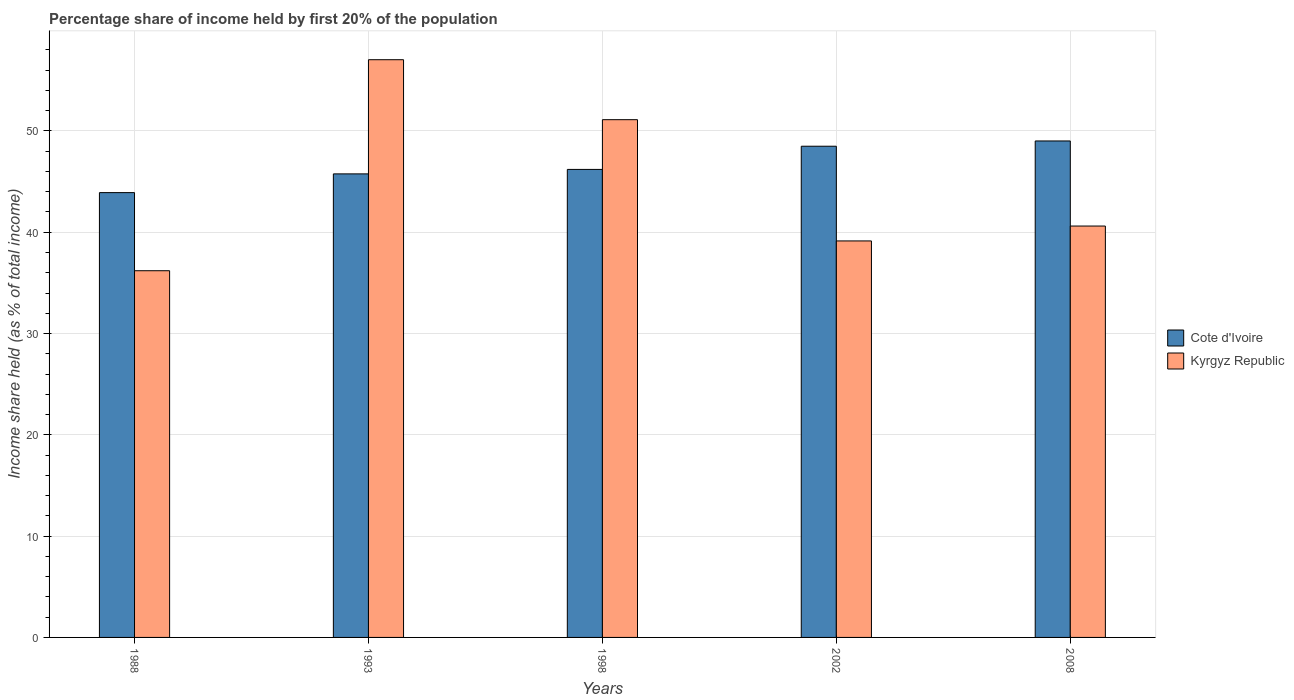Are the number of bars per tick equal to the number of legend labels?
Give a very brief answer. Yes. Are the number of bars on each tick of the X-axis equal?
Make the answer very short. Yes. What is the label of the 2nd group of bars from the left?
Your answer should be very brief. 1993. In how many cases, is the number of bars for a given year not equal to the number of legend labels?
Your answer should be very brief. 0. What is the share of income held by first 20% of the population in Kyrgyz Republic in 2008?
Give a very brief answer. 40.61. Across all years, what is the maximum share of income held by first 20% of the population in Cote d'Ivoire?
Your answer should be very brief. 49.01. Across all years, what is the minimum share of income held by first 20% of the population in Cote d'Ivoire?
Your answer should be very brief. 43.91. What is the total share of income held by first 20% of the population in Kyrgyz Republic in the graph?
Keep it short and to the point. 224.09. What is the difference between the share of income held by first 20% of the population in Kyrgyz Republic in 2002 and that in 2008?
Offer a terse response. -1.47. What is the difference between the share of income held by first 20% of the population in Kyrgyz Republic in 2008 and the share of income held by first 20% of the population in Cote d'Ivoire in 2002?
Keep it short and to the point. -7.88. What is the average share of income held by first 20% of the population in Kyrgyz Republic per year?
Give a very brief answer. 44.82. In the year 2008, what is the difference between the share of income held by first 20% of the population in Kyrgyz Republic and share of income held by first 20% of the population in Cote d'Ivoire?
Provide a succinct answer. -8.4. In how many years, is the share of income held by first 20% of the population in Cote d'Ivoire greater than 24 %?
Offer a terse response. 5. What is the ratio of the share of income held by first 20% of the population in Cote d'Ivoire in 2002 to that in 2008?
Offer a terse response. 0.99. What is the difference between the highest and the second highest share of income held by first 20% of the population in Cote d'Ivoire?
Your response must be concise. 0.52. What is the difference between the highest and the lowest share of income held by first 20% of the population in Kyrgyz Republic?
Keep it short and to the point. 20.83. Is the sum of the share of income held by first 20% of the population in Cote d'Ivoire in 1993 and 2008 greater than the maximum share of income held by first 20% of the population in Kyrgyz Republic across all years?
Offer a very short reply. Yes. What does the 1st bar from the left in 1988 represents?
Your response must be concise. Cote d'Ivoire. What does the 2nd bar from the right in 2002 represents?
Ensure brevity in your answer.  Cote d'Ivoire. How many bars are there?
Offer a very short reply. 10. How many years are there in the graph?
Provide a succinct answer. 5. What is the difference between two consecutive major ticks on the Y-axis?
Make the answer very short. 10. Does the graph contain grids?
Your response must be concise. Yes. Where does the legend appear in the graph?
Ensure brevity in your answer.  Center right. How many legend labels are there?
Offer a very short reply. 2. How are the legend labels stacked?
Offer a terse response. Vertical. What is the title of the graph?
Make the answer very short. Percentage share of income held by first 20% of the population. What is the label or title of the Y-axis?
Offer a very short reply. Income share held (as % of total income). What is the Income share held (as % of total income) in Cote d'Ivoire in 1988?
Your answer should be very brief. 43.91. What is the Income share held (as % of total income) in Kyrgyz Republic in 1988?
Your answer should be compact. 36.2. What is the Income share held (as % of total income) of Cote d'Ivoire in 1993?
Ensure brevity in your answer.  45.76. What is the Income share held (as % of total income) in Kyrgyz Republic in 1993?
Give a very brief answer. 57.03. What is the Income share held (as % of total income) of Cote d'Ivoire in 1998?
Ensure brevity in your answer.  46.2. What is the Income share held (as % of total income) in Kyrgyz Republic in 1998?
Provide a short and direct response. 51.11. What is the Income share held (as % of total income) in Cote d'Ivoire in 2002?
Your response must be concise. 48.49. What is the Income share held (as % of total income) in Kyrgyz Republic in 2002?
Your response must be concise. 39.14. What is the Income share held (as % of total income) in Cote d'Ivoire in 2008?
Offer a terse response. 49.01. What is the Income share held (as % of total income) of Kyrgyz Republic in 2008?
Offer a very short reply. 40.61. Across all years, what is the maximum Income share held (as % of total income) in Cote d'Ivoire?
Offer a terse response. 49.01. Across all years, what is the maximum Income share held (as % of total income) in Kyrgyz Republic?
Keep it short and to the point. 57.03. Across all years, what is the minimum Income share held (as % of total income) in Cote d'Ivoire?
Offer a very short reply. 43.91. Across all years, what is the minimum Income share held (as % of total income) of Kyrgyz Republic?
Give a very brief answer. 36.2. What is the total Income share held (as % of total income) in Cote d'Ivoire in the graph?
Your response must be concise. 233.37. What is the total Income share held (as % of total income) in Kyrgyz Republic in the graph?
Your answer should be compact. 224.09. What is the difference between the Income share held (as % of total income) of Cote d'Ivoire in 1988 and that in 1993?
Provide a succinct answer. -1.85. What is the difference between the Income share held (as % of total income) of Kyrgyz Republic in 1988 and that in 1993?
Offer a very short reply. -20.83. What is the difference between the Income share held (as % of total income) of Cote d'Ivoire in 1988 and that in 1998?
Keep it short and to the point. -2.29. What is the difference between the Income share held (as % of total income) of Kyrgyz Republic in 1988 and that in 1998?
Provide a succinct answer. -14.91. What is the difference between the Income share held (as % of total income) in Cote d'Ivoire in 1988 and that in 2002?
Keep it short and to the point. -4.58. What is the difference between the Income share held (as % of total income) of Kyrgyz Republic in 1988 and that in 2002?
Keep it short and to the point. -2.94. What is the difference between the Income share held (as % of total income) of Kyrgyz Republic in 1988 and that in 2008?
Your answer should be compact. -4.41. What is the difference between the Income share held (as % of total income) of Cote d'Ivoire in 1993 and that in 1998?
Your answer should be very brief. -0.44. What is the difference between the Income share held (as % of total income) in Kyrgyz Republic in 1993 and that in 1998?
Make the answer very short. 5.92. What is the difference between the Income share held (as % of total income) in Cote d'Ivoire in 1993 and that in 2002?
Provide a short and direct response. -2.73. What is the difference between the Income share held (as % of total income) of Kyrgyz Republic in 1993 and that in 2002?
Provide a short and direct response. 17.89. What is the difference between the Income share held (as % of total income) in Cote d'Ivoire in 1993 and that in 2008?
Keep it short and to the point. -3.25. What is the difference between the Income share held (as % of total income) in Kyrgyz Republic in 1993 and that in 2008?
Your response must be concise. 16.42. What is the difference between the Income share held (as % of total income) of Cote d'Ivoire in 1998 and that in 2002?
Make the answer very short. -2.29. What is the difference between the Income share held (as % of total income) in Kyrgyz Republic in 1998 and that in 2002?
Provide a succinct answer. 11.97. What is the difference between the Income share held (as % of total income) in Cote d'Ivoire in 1998 and that in 2008?
Offer a terse response. -2.81. What is the difference between the Income share held (as % of total income) of Cote d'Ivoire in 2002 and that in 2008?
Ensure brevity in your answer.  -0.52. What is the difference between the Income share held (as % of total income) in Kyrgyz Republic in 2002 and that in 2008?
Offer a terse response. -1.47. What is the difference between the Income share held (as % of total income) of Cote d'Ivoire in 1988 and the Income share held (as % of total income) of Kyrgyz Republic in 1993?
Provide a short and direct response. -13.12. What is the difference between the Income share held (as % of total income) of Cote d'Ivoire in 1988 and the Income share held (as % of total income) of Kyrgyz Republic in 2002?
Provide a succinct answer. 4.77. What is the difference between the Income share held (as % of total income) in Cote d'Ivoire in 1993 and the Income share held (as % of total income) in Kyrgyz Republic in 1998?
Provide a succinct answer. -5.35. What is the difference between the Income share held (as % of total income) of Cote d'Ivoire in 1993 and the Income share held (as % of total income) of Kyrgyz Republic in 2002?
Give a very brief answer. 6.62. What is the difference between the Income share held (as % of total income) of Cote d'Ivoire in 1993 and the Income share held (as % of total income) of Kyrgyz Republic in 2008?
Make the answer very short. 5.15. What is the difference between the Income share held (as % of total income) of Cote d'Ivoire in 1998 and the Income share held (as % of total income) of Kyrgyz Republic in 2002?
Keep it short and to the point. 7.06. What is the difference between the Income share held (as % of total income) in Cote d'Ivoire in 1998 and the Income share held (as % of total income) in Kyrgyz Republic in 2008?
Your response must be concise. 5.59. What is the difference between the Income share held (as % of total income) of Cote d'Ivoire in 2002 and the Income share held (as % of total income) of Kyrgyz Republic in 2008?
Your response must be concise. 7.88. What is the average Income share held (as % of total income) in Cote d'Ivoire per year?
Provide a short and direct response. 46.67. What is the average Income share held (as % of total income) in Kyrgyz Republic per year?
Your answer should be compact. 44.82. In the year 1988, what is the difference between the Income share held (as % of total income) in Cote d'Ivoire and Income share held (as % of total income) in Kyrgyz Republic?
Keep it short and to the point. 7.71. In the year 1993, what is the difference between the Income share held (as % of total income) of Cote d'Ivoire and Income share held (as % of total income) of Kyrgyz Republic?
Your answer should be very brief. -11.27. In the year 1998, what is the difference between the Income share held (as % of total income) of Cote d'Ivoire and Income share held (as % of total income) of Kyrgyz Republic?
Give a very brief answer. -4.91. In the year 2002, what is the difference between the Income share held (as % of total income) in Cote d'Ivoire and Income share held (as % of total income) in Kyrgyz Republic?
Provide a succinct answer. 9.35. What is the ratio of the Income share held (as % of total income) of Cote d'Ivoire in 1988 to that in 1993?
Offer a very short reply. 0.96. What is the ratio of the Income share held (as % of total income) in Kyrgyz Republic in 1988 to that in 1993?
Make the answer very short. 0.63. What is the ratio of the Income share held (as % of total income) of Cote d'Ivoire in 1988 to that in 1998?
Offer a very short reply. 0.95. What is the ratio of the Income share held (as % of total income) of Kyrgyz Republic in 1988 to that in 1998?
Offer a terse response. 0.71. What is the ratio of the Income share held (as % of total income) of Cote d'Ivoire in 1988 to that in 2002?
Make the answer very short. 0.91. What is the ratio of the Income share held (as % of total income) in Kyrgyz Republic in 1988 to that in 2002?
Give a very brief answer. 0.92. What is the ratio of the Income share held (as % of total income) of Cote d'Ivoire in 1988 to that in 2008?
Provide a short and direct response. 0.9. What is the ratio of the Income share held (as % of total income) in Kyrgyz Republic in 1988 to that in 2008?
Make the answer very short. 0.89. What is the ratio of the Income share held (as % of total income) in Cote d'Ivoire in 1993 to that in 1998?
Your response must be concise. 0.99. What is the ratio of the Income share held (as % of total income) of Kyrgyz Republic in 1993 to that in 1998?
Provide a succinct answer. 1.12. What is the ratio of the Income share held (as % of total income) in Cote d'Ivoire in 1993 to that in 2002?
Make the answer very short. 0.94. What is the ratio of the Income share held (as % of total income) of Kyrgyz Republic in 1993 to that in 2002?
Offer a very short reply. 1.46. What is the ratio of the Income share held (as % of total income) of Cote d'Ivoire in 1993 to that in 2008?
Ensure brevity in your answer.  0.93. What is the ratio of the Income share held (as % of total income) of Kyrgyz Republic in 1993 to that in 2008?
Offer a terse response. 1.4. What is the ratio of the Income share held (as % of total income) in Cote d'Ivoire in 1998 to that in 2002?
Provide a short and direct response. 0.95. What is the ratio of the Income share held (as % of total income) in Kyrgyz Republic in 1998 to that in 2002?
Your answer should be compact. 1.31. What is the ratio of the Income share held (as % of total income) of Cote d'Ivoire in 1998 to that in 2008?
Provide a short and direct response. 0.94. What is the ratio of the Income share held (as % of total income) in Kyrgyz Republic in 1998 to that in 2008?
Your answer should be very brief. 1.26. What is the ratio of the Income share held (as % of total income) of Cote d'Ivoire in 2002 to that in 2008?
Keep it short and to the point. 0.99. What is the ratio of the Income share held (as % of total income) in Kyrgyz Republic in 2002 to that in 2008?
Provide a short and direct response. 0.96. What is the difference between the highest and the second highest Income share held (as % of total income) in Cote d'Ivoire?
Ensure brevity in your answer.  0.52. What is the difference between the highest and the second highest Income share held (as % of total income) of Kyrgyz Republic?
Provide a short and direct response. 5.92. What is the difference between the highest and the lowest Income share held (as % of total income) of Cote d'Ivoire?
Make the answer very short. 5.1. What is the difference between the highest and the lowest Income share held (as % of total income) in Kyrgyz Republic?
Your answer should be compact. 20.83. 